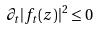<formula> <loc_0><loc_0><loc_500><loc_500>\partial _ { t } | f _ { t } ( z ) | ^ { 2 } \leq 0</formula> 